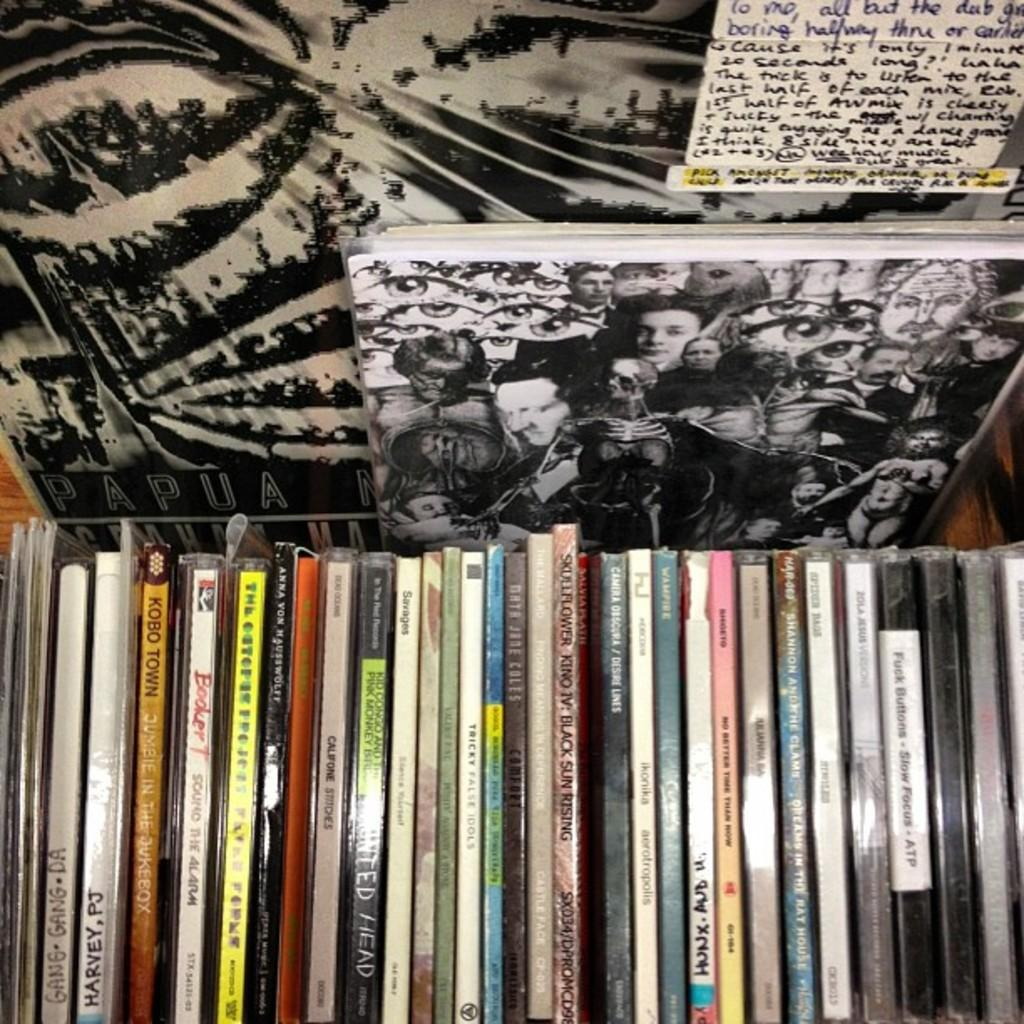<image>
Relay a brief, clear account of the picture shown. Many albums on a table including one that says HARVEY, PJ. 